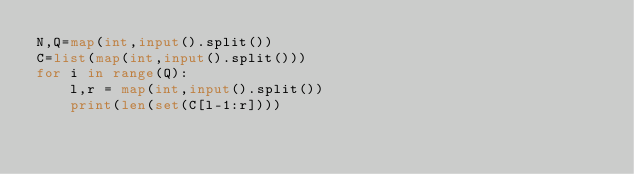<code> <loc_0><loc_0><loc_500><loc_500><_Python_>N,Q=map(int,input().split())
C=list(map(int,input().split()))
for i in range(Q):
    l,r = map(int,input().split())
    print(len(set(C[l-1:r])))
</code> 